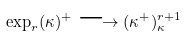Convert formula to latex. <formula><loc_0><loc_0><loc_500><loc_500>\exp _ { r } ( \kappa ) ^ { + } \longrightarrow ( \kappa ^ { + } ) _ { \kappa } ^ { r + 1 }</formula> 